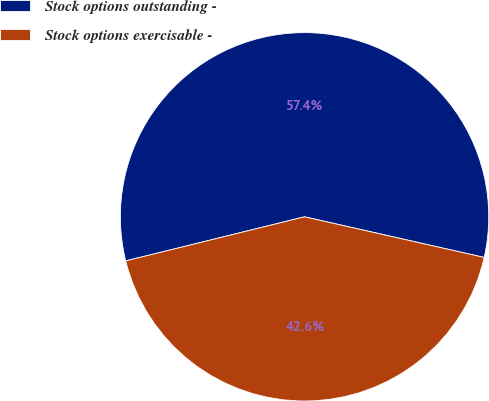Convert chart. <chart><loc_0><loc_0><loc_500><loc_500><pie_chart><fcel>Stock options outstanding -<fcel>Stock options exercisable -<nl><fcel>57.39%<fcel>42.61%<nl></chart> 